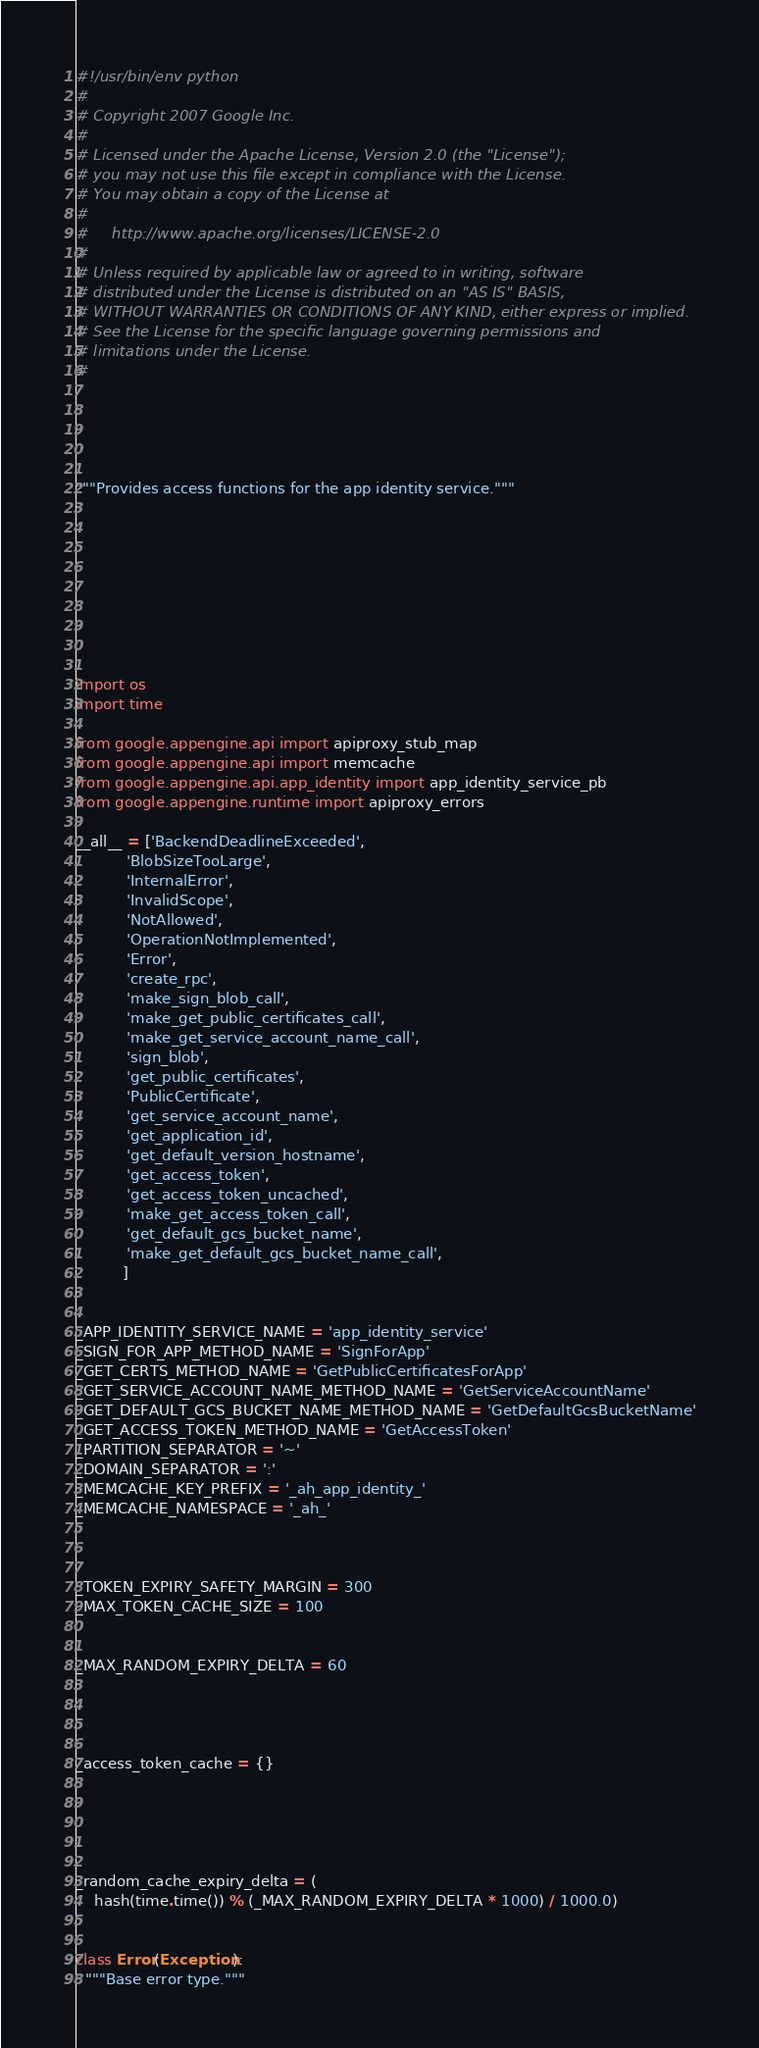<code> <loc_0><loc_0><loc_500><loc_500><_Python_>#!/usr/bin/env python
#
# Copyright 2007 Google Inc.
#
# Licensed under the Apache License, Version 2.0 (the "License");
# you may not use this file except in compliance with the License.
# You may obtain a copy of the License at
#
#     http://www.apache.org/licenses/LICENSE-2.0
#
# Unless required by applicable law or agreed to in writing, software
# distributed under the License is distributed on an "AS IS" BASIS,
# WITHOUT WARRANTIES OR CONDITIONS OF ANY KIND, either express or implied.
# See the License for the specific language governing permissions and
# limitations under the License.
#





"""Provides access functions for the app identity service."""









import os
import time

from google.appengine.api import apiproxy_stub_map
from google.appengine.api import memcache
from google.appengine.api.app_identity import app_identity_service_pb
from google.appengine.runtime import apiproxy_errors

__all__ = ['BackendDeadlineExceeded',
           'BlobSizeTooLarge',
           'InternalError',
           'InvalidScope',
           'NotAllowed',
           'OperationNotImplemented',
           'Error',
           'create_rpc',
           'make_sign_blob_call',
           'make_get_public_certificates_call',
           'make_get_service_account_name_call',
           'sign_blob',
           'get_public_certificates',
           'PublicCertificate',
           'get_service_account_name',
           'get_application_id',
           'get_default_version_hostname',
           'get_access_token',
           'get_access_token_uncached',
           'make_get_access_token_call',
           'get_default_gcs_bucket_name',
           'make_get_default_gcs_bucket_name_call',
          ]


_APP_IDENTITY_SERVICE_NAME = 'app_identity_service'
_SIGN_FOR_APP_METHOD_NAME = 'SignForApp'
_GET_CERTS_METHOD_NAME = 'GetPublicCertificatesForApp'
_GET_SERVICE_ACCOUNT_NAME_METHOD_NAME = 'GetServiceAccountName'
_GET_DEFAULT_GCS_BUCKET_NAME_METHOD_NAME = 'GetDefaultGcsBucketName'
_GET_ACCESS_TOKEN_METHOD_NAME = 'GetAccessToken'
_PARTITION_SEPARATOR = '~'
_DOMAIN_SEPARATOR = ':'
_MEMCACHE_KEY_PREFIX = '_ah_app_identity_'
_MEMCACHE_NAMESPACE = '_ah_'



_TOKEN_EXPIRY_SAFETY_MARGIN = 300
_MAX_TOKEN_CACHE_SIZE = 100


_MAX_RANDOM_EXPIRY_DELTA = 60




_access_token_cache = {}





_random_cache_expiry_delta = (
    hash(time.time()) % (_MAX_RANDOM_EXPIRY_DELTA * 1000) / 1000.0)


class Error(Exception):
  """Base error type."""

</code> 